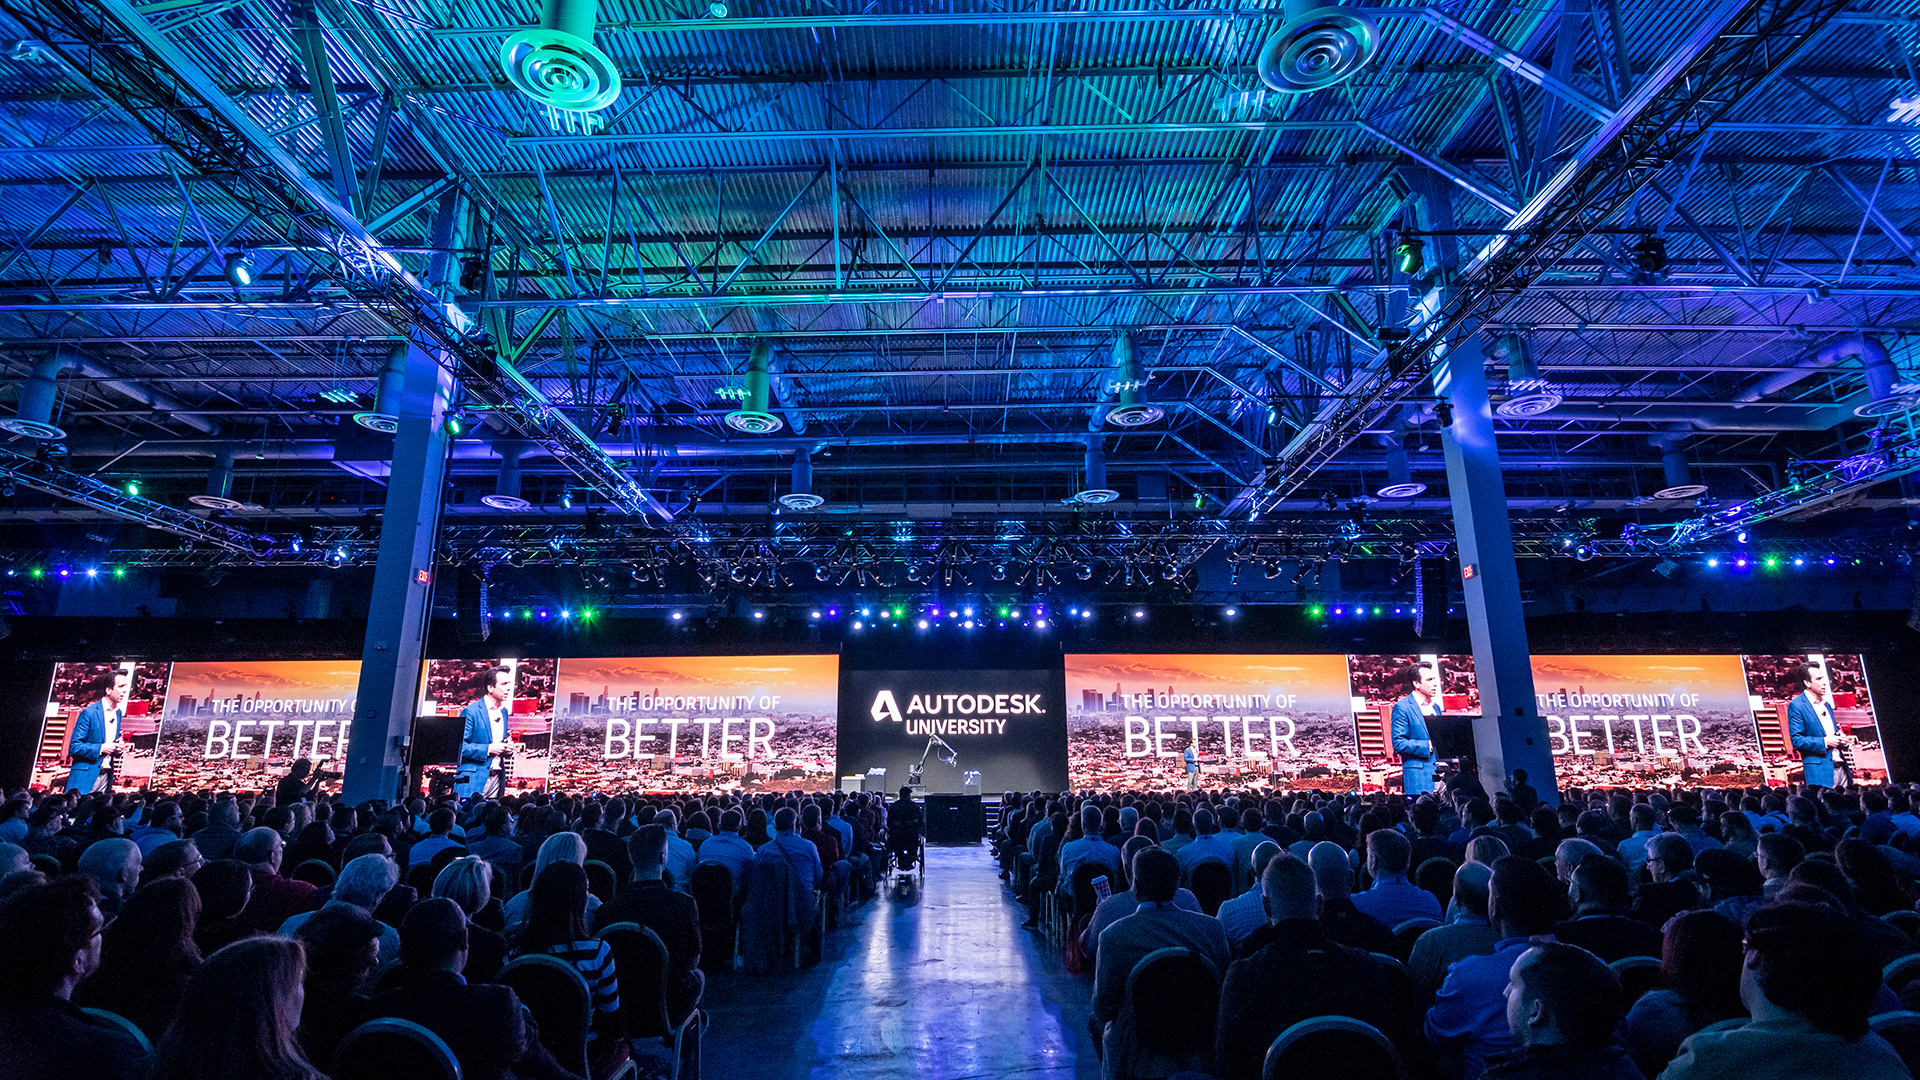What role could artificial intelligence (AI) play in enhancing the presentations and discussions during this event? Artificial intelligence (AI) could significantly enhance the presentations and discussions at this event. AI-powered tools could be used to analyze vast amounts of data in real-time, providing presenters with insights and trends relevant to their talks. AI-driven virtual assistants might help in answering audience questions more efficiently or in generating on-the-fly visualizations of complex concepts. During collaborative sessions, AI could facilitate brainstorming by suggesting ideas or optimizing designs based on predetermined criteria. Furthermore, AI could personalize the learning experience for attendees by tailoring content recommendations based on their interests and professional backgrounds, making the event more engaging and informative for everyone. Could AI also be used in a creative way at this event? If so, how? Absolutely! AI could be used creatively at this event in several ways. For instance, AI algorithms could generate artistic visualizations or designs based on certain parameters, showcasing the intersection of technology and creativity in design. AI could also be employed in creating interactive installations or art pieces that respond to attendee inputs, making the event more dynamic and interactive. Additionally, AI-driven generative models could compose music or soundscapes tailored to different parts of the event, enhancing the overall experience. In workshops, AI could assist in developing unique architectural designs or animation sequences, pushing the boundaries of what’s possible with current technology. 